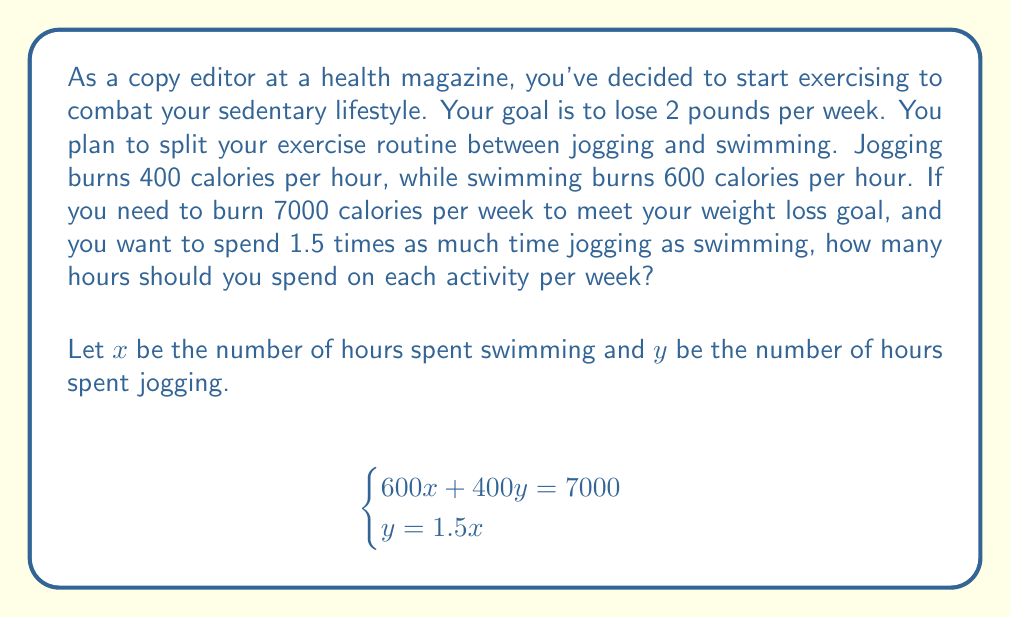Can you answer this question? To solve this system of equations, we'll use the substitution method:

1) From the second equation, we know that $y = 1.5x$. Let's substitute this into the first equation:

   $$600x + 400(1.5x) = 7000$$

2) Simplify the left side of the equation:

   $$600x + 600x = 7000$$
   $$1200x = 7000$$

3) Solve for $x$:

   $$x = \frac{7000}{1200} = \frac{35}{6} \approx 5.83$$

4) Now that we know $x$, we can find $y$ using the second equation:

   $$y = 1.5x = 1.5 \cdot \frac{35}{6} = \frac{35}{4} = 8.75$$

5) Therefore, you should spend approximately 5.83 hours swimming and 8.75 hours jogging per week.

6) Let's verify:
   Calories burned swimming: $600 \cdot 5.83 \approx 3500$
   Calories burned jogging: $400 \cdot 8.75 = 3500$
   Total: $3500 + 3500 = 7000$ calories, which meets the goal.
Answer: Swimming: $\frac{35}{6}$ hours, Jogging: $\frac{35}{4}$ hours 